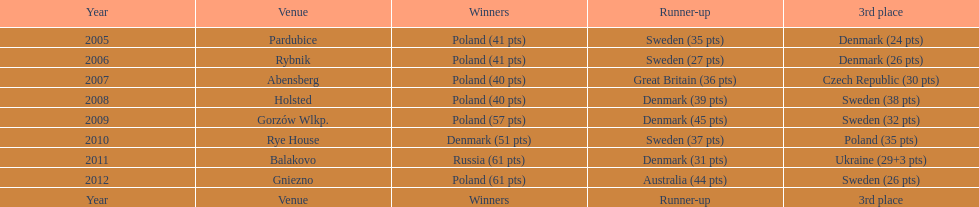What was the difference in final score between russia and denmark in 2011? 30. 